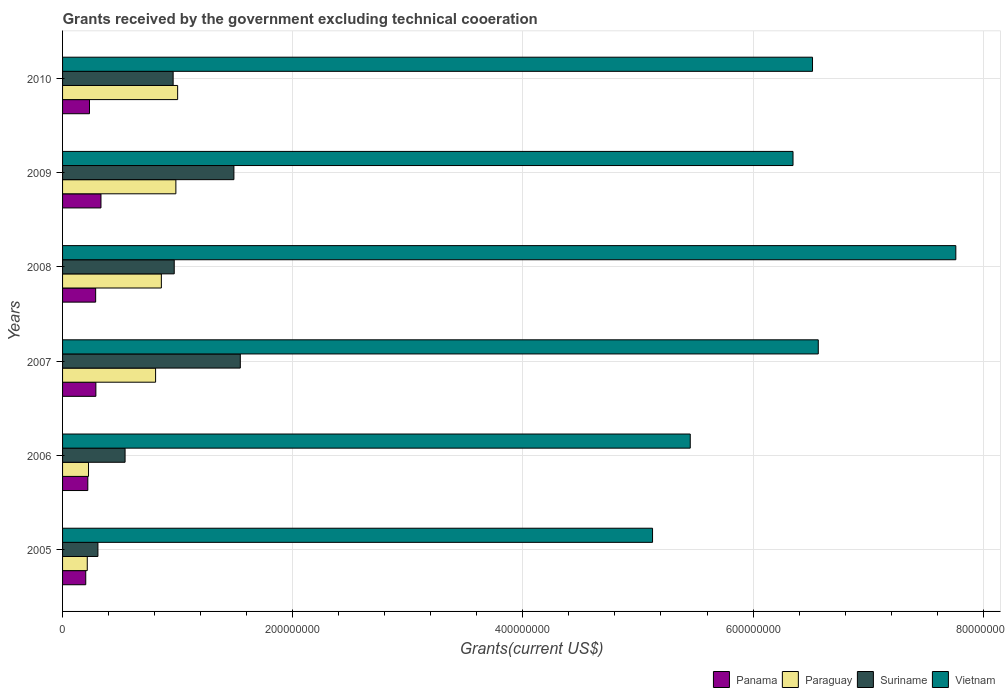Are the number of bars per tick equal to the number of legend labels?
Keep it short and to the point. Yes. Are the number of bars on each tick of the Y-axis equal?
Offer a very short reply. Yes. How many bars are there on the 6th tick from the bottom?
Your response must be concise. 4. What is the label of the 6th group of bars from the top?
Provide a succinct answer. 2005. In how many cases, is the number of bars for a given year not equal to the number of legend labels?
Your answer should be very brief. 0. What is the total grants received by the government in Panama in 2005?
Make the answer very short. 2.02e+07. Across all years, what is the maximum total grants received by the government in Panama?
Offer a terse response. 3.34e+07. Across all years, what is the minimum total grants received by the government in Vietnam?
Keep it short and to the point. 5.13e+08. In which year was the total grants received by the government in Vietnam maximum?
Offer a terse response. 2008. In which year was the total grants received by the government in Panama minimum?
Provide a short and direct response. 2005. What is the total total grants received by the government in Vietnam in the graph?
Your answer should be very brief. 3.78e+09. What is the difference between the total grants received by the government in Paraguay in 2009 and that in 2010?
Give a very brief answer. -1.53e+06. What is the difference between the total grants received by the government in Paraguay in 2006 and the total grants received by the government in Suriname in 2007?
Provide a short and direct response. -1.32e+08. What is the average total grants received by the government in Paraguay per year?
Offer a terse response. 6.82e+07. In the year 2008, what is the difference between the total grants received by the government in Panama and total grants received by the government in Vietnam?
Your response must be concise. -7.47e+08. In how many years, is the total grants received by the government in Paraguay greater than 160000000 US$?
Provide a succinct answer. 0. What is the ratio of the total grants received by the government in Paraguay in 2006 to that in 2009?
Provide a short and direct response. 0.23. Is the total grants received by the government in Panama in 2007 less than that in 2008?
Offer a very short reply. No. Is the difference between the total grants received by the government in Panama in 2006 and 2007 greater than the difference between the total grants received by the government in Vietnam in 2006 and 2007?
Ensure brevity in your answer.  Yes. What is the difference between the highest and the second highest total grants received by the government in Vietnam?
Make the answer very short. 1.20e+08. What is the difference between the highest and the lowest total grants received by the government in Paraguay?
Make the answer very short. 7.85e+07. Is the sum of the total grants received by the government in Suriname in 2005 and 2010 greater than the maximum total grants received by the government in Panama across all years?
Make the answer very short. Yes. What does the 2nd bar from the top in 2006 represents?
Provide a short and direct response. Suriname. What does the 3rd bar from the bottom in 2006 represents?
Keep it short and to the point. Suriname. Is it the case that in every year, the sum of the total grants received by the government in Vietnam and total grants received by the government in Suriname is greater than the total grants received by the government in Panama?
Make the answer very short. Yes. What is the difference between two consecutive major ticks on the X-axis?
Ensure brevity in your answer.  2.00e+08. Does the graph contain any zero values?
Make the answer very short. No. Where does the legend appear in the graph?
Make the answer very short. Bottom right. What is the title of the graph?
Ensure brevity in your answer.  Grants received by the government excluding technical cooeration. Does "Ethiopia" appear as one of the legend labels in the graph?
Make the answer very short. No. What is the label or title of the X-axis?
Keep it short and to the point. Grants(current US$). What is the label or title of the Y-axis?
Your answer should be very brief. Years. What is the Grants(current US$) in Panama in 2005?
Ensure brevity in your answer.  2.02e+07. What is the Grants(current US$) of Paraguay in 2005?
Your answer should be compact. 2.15e+07. What is the Grants(current US$) in Suriname in 2005?
Give a very brief answer. 3.07e+07. What is the Grants(current US$) in Vietnam in 2005?
Your response must be concise. 5.13e+08. What is the Grants(current US$) in Panama in 2006?
Provide a short and direct response. 2.19e+07. What is the Grants(current US$) in Paraguay in 2006?
Give a very brief answer. 2.26e+07. What is the Grants(current US$) of Suriname in 2006?
Your answer should be compact. 5.43e+07. What is the Grants(current US$) in Vietnam in 2006?
Your response must be concise. 5.45e+08. What is the Grants(current US$) of Panama in 2007?
Provide a short and direct response. 2.90e+07. What is the Grants(current US$) of Paraguay in 2007?
Give a very brief answer. 8.08e+07. What is the Grants(current US$) in Suriname in 2007?
Ensure brevity in your answer.  1.54e+08. What is the Grants(current US$) in Vietnam in 2007?
Provide a short and direct response. 6.57e+08. What is the Grants(current US$) in Panama in 2008?
Keep it short and to the point. 2.88e+07. What is the Grants(current US$) of Paraguay in 2008?
Keep it short and to the point. 8.58e+07. What is the Grants(current US$) in Suriname in 2008?
Your response must be concise. 9.70e+07. What is the Grants(current US$) in Vietnam in 2008?
Give a very brief answer. 7.76e+08. What is the Grants(current US$) in Panama in 2009?
Ensure brevity in your answer.  3.34e+07. What is the Grants(current US$) of Paraguay in 2009?
Offer a very short reply. 9.85e+07. What is the Grants(current US$) of Suriname in 2009?
Your answer should be compact. 1.49e+08. What is the Grants(current US$) of Vietnam in 2009?
Give a very brief answer. 6.35e+08. What is the Grants(current US$) in Panama in 2010?
Provide a short and direct response. 2.34e+07. What is the Grants(current US$) of Paraguay in 2010?
Make the answer very short. 1.00e+08. What is the Grants(current US$) of Suriname in 2010?
Provide a succinct answer. 9.61e+07. What is the Grants(current US$) of Vietnam in 2010?
Give a very brief answer. 6.52e+08. Across all years, what is the maximum Grants(current US$) of Panama?
Provide a succinct answer. 3.34e+07. Across all years, what is the maximum Grants(current US$) of Paraguay?
Offer a very short reply. 1.00e+08. Across all years, what is the maximum Grants(current US$) of Suriname?
Offer a terse response. 1.54e+08. Across all years, what is the maximum Grants(current US$) of Vietnam?
Offer a very short reply. 7.76e+08. Across all years, what is the minimum Grants(current US$) of Panama?
Offer a terse response. 2.02e+07. Across all years, what is the minimum Grants(current US$) in Paraguay?
Provide a succinct answer. 2.15e+07. Across all years, what is the minimum Grants(current US$) of Suriname?
Keep it short and to the point. 3.07e+07. Across all years, what is the minimum Grants(current US$) of Vietnam?
Your response must be concise. 5.13e+08. What is the total Grants(current US$) of Panama in the graph?
Offer a very short reply. 1.57e+08. What is the total Grants(current US$) of Paraguay in the graph?
Make the answer very short. 4.09e+08. What is the total Grants(current US$) of Suriname in the graph?
Your answer should be compact. 5.82e+08. What is the total Grants(current US$) in Vietnam in the graph?
Ensure brevity in your answer.  3.78e+09. What is the difference between the Grants(current US$) in Panama in 2005 and that in 2006?
Give a very brief answer. -1.79e+06. What is the difference between the Grants(current US$) in Paraguay in 2005 and that in 2006?
Provide a short and direct response. -1.09e+06. What is the difference between the Grants(current US$) of Suriname in 2005 and that in 2006?
Provide a succinct answer. -2.36e+07. What is the difference between the Grants(current US$) in Vietnam in 2005 and that in 2006?
Offer a terse response. -3.28e+07. What is the difference between the Grants(current US$) of Panama in 2005 and that in 2007?
Provide a short and direct response. -8.80e+06. What is the difference between the Grants(current US$) of Paraguay in 2005 and that in 2007?
Ensure brevity in your answer.  -5.94e+07. What is the difference between the Grants(current US$) in Suriname in 2005 and that in 2007?
Your response must be concise. -1.24e+08. What is the difference between the Grants(current US$) of Vietnam in 2005 and that in 2007?
Ensure brevity in your answer.  -1.44e+08. What is the difference between the Grants(current US$) of Panama in 2005 and that in 2008?
Ensure brevity in your answer.  -8.61e+06. What is the difference between the Grants(current US$) in Paraguay in 2005 and that in 2008?
Offer a very short reply. -6.44e+07. What is the difference between the Grants(current US$) in Suriname in 2005 and that in 2008?
Give a very brief answer. -6.63e+07. What is the difference between the Grants(current US$) of Vietnam in 2005 and that in 2008?
Your answer should be very brief. -2.64e+08. What is the difference between the Grants(current US$) in Panama in 2005 and that in 2009?
Offer a terse response. -1.32e+07. What is the difference between the Grants(current US$) of Paraguay in 2005 and that in 2009?
Provide a succinct answer. -7.70e+07. What is the difference between the Grants(current US$) of Suriname in 2005 and that in 2009?
Provide a succinct answer. -1.18e+08. What is the difference between the Grants(current US$) in Vietnam in 2005 and that in 2009?
Keep it short and to the point. -1.22e+08. What is the difference between the Grants(current US$) in Panama in 2005 and that in 2010?
Your answer should be compact. -3.26e+06. What is the difference between the Grants(current US$) in Paraguay in 2005 and that in 2010?
Your response must be concise. -7.85e+07. What is the difference between the Grants(current US$) of Suriname in 2005 and that in 2010?
Offer a terse response. -6.54e+07. What is the difference between the Grants(current US$) of Vietnam in 2005 and that in 2010?
Offer a very short reply. -1.39e+08. What is the difference between the Grants(current US$) of Panama in 2006 and that in 2007?
Provide a succinct answer. -7.01e+06. What is the difference between the Grants(current US$) in Paraguay in 2006 and that in 2007?
Offer a very short reply. -5.83e+07. What is the difference between the Grants(current US$) of Suriname in 2006 and that in 2007?
Keep it short and to the point. -1.00e+08. What is the difference between the Grants(current US$) in Vietnam in 2006 and that in 2007?
Offer a very short reply. -1.11e+08. What is the difference between the Grants(current US$) of Panama in 2006 and that in 2008?
Offer a very short reply. -6.82e+06. What is the difference between the Grants(current US$) in Paraguay in 2006 and that in 2008?
Your answer should be very brief. -6.33e+07. What is the difference between the Grants(current US$) in Suriname in 2006 and that in 2008?
Your answer should be compact. -4.27e+07. What is the difference between the Grants(current US$) of Vietnam in 2006 and that in 2008?
Your answer should be very brief. -2.31e+08. What is the difference between the Grants(current US$) of Panama in 2006 and that in 2009?
Your answer should be compact. -1.14e+07. What is the difference between the Grants(current US$) in Paraguay in 2006 and that in 2009?
Offer a very short reply. -7.59e+07. What is the difference between the Grants(current US$) in Suriname in 2006 and that in 2009?
Ensure brevity in your answer.  -9.46e+07. What is the difference between the Grants(current US$) in Vietnam in 2006 and that in 2009?
Keep it short and to the point. -8.93e+07. What is the difference between the Grants(current US$) of Panama in 2006 and that in 2010?
Your response must be concise. -1.47e+06. What is the difference between the Grants(current US$) in Paraguay in 2006 and that in 2010?
Make the answer very short. -7.74e+07. What is the difference between the Grants(current US$) of Suriname in 2006 and that in 2010?
Make the answer very short. -4.18e+07. What is the difference between the Grants(current US$) in Vietnam in 2006 and that in 2010?
Your response must be concise. -1.06e+08. What is the difference between the Grants(current US$) of Panama in 2007 and that in 2008?
Make the answer very short. 1.90e+05. What is the difference between the Grants(current US$) of Paraguay in 2007 and that in 2008?
Provide a short and direct response. -5.01e+06. What is the difference between the Grants(current US$) of Suriname in 2007 and that in 2008?
Provide a short and direct response. 5.74e+07. What is the difference between the Grants(current US$) of Vietnam in 2007 and that in 2008?
Your answer should be compact. -1.20e+08. What is the difference between the Grants(current US$) of Panama in 2007 and that in 2009?
Offer a terse response. -4.42e+06. What is the difference between the Grants(current US$) in Paraguay in 2007 and that in 2009?
Your answer should be very brief. -1.76e+07. What is the difference between the Grants(current US$) in Suriname in 2007 and that in 2009?
Your response must be concise. 5.56e+06. What is the difference between the Grants(current US$) of Vietnam in 2007 and that in 2009?
Your response must be concise. 2.20e+07. What is the difference between the Grants(current US$) in Panama in 2007 and that in 2010?
Your answer should be very brief. 5.54e+06. What is the difference between the Grants(current US$) of Paraguay in 2007 and that in 2010?
Provide a succinct answer. -1.92e+07. What is the difference between the Grants(current US$) of Suriname in 2007 and that in 2010?
Ensure brevity in your answer.  5.84e+07. What is the difference between the Grants(current US$) in Vietnam in 2007 and that in 2010?
Offer a very short reply. 5.01e+06. What is the difference between the Grants(current US$) of Panama in 2008 and that in 2009?
Provide a succinct answer. -4.61e+06. What is the difference between the Grants(current US$) in Paraguay in 2008 and that in 2009?
Your response must be concise. -1.26e+07. What is the difference between the Grants(current US$) in Suriname in 2008 and that in 2009?
Make the answer very short. -5.19e+07. What is the difference between the Grants(current US$) in Vietnam in 2008 and that in 2009?
Offer a terse response. 1.41e+08. What is the difference between the Grants(current US$) of Panama in 2008 and that in 2010?
Your response must be concise. 5.35e+06. What is the difference between the Grants(current US$) in Paraguay in 2008 and that in 2010?
Offer a terse response. -1.41e+07. What is the difference between the Grants(current US$) in Suriname in 2008 and that in 2010?
Offer a terse response. 9.40e+05. What is the difference between the Grants(current US$) in Vietnam in 2008 and that in 2010?
Your response must be concise. 1.25e+08. What is the difference between the Grants(current US$) of Panama in 2009 and that in 2010?
Keep it short and to the point. 9.96e+06. What is the difference between the Grants(current US$) in Paraguay in 2009 and that in 2010?
Ensure brevity in your answer.  -1.53e+06. What is the difference between the Grants(current US$) of Suriname in 2009 and that in 2010?
Offer a terse response. 5.28e+07. What is the difference between the Grants(current US$) of Vietnam in 2009 and that in 2010?
Provide a short and direct response. -1.70e+07. What is the difference between the Grants(current US$) in Panama in 2005 and the Grants(current US$) in Paraguay in 2006?
Make the answer very short. -2.40e+06. What is the difference between the Grants(current US$) in Panama in 2005 and the Grants(current US$) in Suriname in 2006?
Your response must be concise. -3.42e+07. What is the difference between the Grants(current US$) of Panama in 2005 and the Grants(current US$) of Vietnam in 2006?
Give a very brief answer. -5.25e+08. What is the difference between the Grants(current US$) of Paraguay in 2005 and the Grants(current US$) of Suriname in 2006?
Give a very brief answer. -3.29e+07. What is the difference between the Grants(current US$) in Paraguay in 2005 and the Grants(current US$) in Vietnam in 2006?
Provide a succinct answer. -5.24e+08. What is the difference between the Grants(current US$) in Suriname in 2005 and the Grants(current US$) in Vietnam in 2006?
Make the answer very short. -5.15e+08. What is the difference between the Grants(current US$) of Panama in 2005 and the Grants(current US$) of Paraguay in 2007?
Make the answer very short. -6.07e+07. What is the difference between the Grants(current US$) in Panama in 2005 and the Grants(current US$) in Suriname in 2007?
Ensure brevity in your answer.  -1.34e+08. What is the difference between the Grants(current US$) in Panama in 2005 and the Grants(current US$) in Vietnam in 2007?
Provide a succinct answer. -6.37e+08. What is the difference between the Grants(current US$) in Paraguay in 2005 and the Grants(current US$) in Suriname in 2007?
Offer a terse response. -1.33e+08. What is the difference between the Grants(current US$) in Paraguay in 2005 and the Grants(current US$) in Vietnam in 2007?
Offer a terse response. -6.35e+08. What is the difference between the Grants(current US$) of Suriname in 2005 and the Grants(current US$) of Vietnam in 2007?
Your answer should be very brief. -6.26e+08. What is the difference between the Grants(current US$) in Panama in 2005 and the Grants(current US$) in Paraguay in 2008?
Ensure brevity in your answer.  -6.57e+07. What is the difference between the Grants(current US$) in Panama in 2005 and the Grants(current US$) in Suriname in 2008?
Give a very brief answer. -7.69e+07. What is the difference between the Grants(current US$) of Panama in 2005 and the Grants(current US$) of Vietnam in 2008?
Make the answer very short. -7.56e+08. What is the difference between the Grants(current US$) in Paraguay in 2005 and the Grants(current US$) in Suriname in 2008?
Give a very brief answer. -7.56e+07. What is the difference between the Grants(current US$) in Paraguay in 2005 and the Grants(current US$) in Vietnam in 2008?
Offer a very short reply. -7.55e+08. What is the difference between the Grants(current US$) of Suriname in 2005 and the Grants(current US$) of Vietnam in 2008?
Your answer should be very brief. -7.45e+08. What is the difference between the Grants(current US$) in Panama in 2005 and the Grants(current US$) in Paraguay in 2009?
Ensure brevity in your answer.  -7.83e+07. What is the difference between the Grants(current US$) of Panama in 2005 and the Grants(current US$) of Suriname in 2009?
Your answer should be compact. -1.29e+08. What is the difference between the Grants(current US$) of Panama in 2005 and the Grants(current US$) of Vietnam in 2009?
Provide a short and direct response. -6.15e+08. What is the difference between the Grants(current US$) of Paraguay in 2005 and the Grants(current US$) of Suriname in 2009?
Make the answer very short. -1.27e+08. What is the difference between the Grants(current US$) of Paraguay in 2005 and the Grants(current US$) of Vietnam in 2009?
Offer a very short reply. -6.13e+08. What is the difference between the Grants(current US$) in Suriname in 2005 and the Grants(current US$) in Vietnam in 2009?
Make the answer very short. -6.04e+08. What is the difference between the Grants(current US$) in Panama in 2005 and the Grants(current US$) in Paraguay in 2010?
Offer a very short reply. -7.98e+07. What is the difference between the Grants(current US$) in Panama in 2005 and the Grants(current US$) in Suriname in 2010?
Give a very brief answer. -7.59e+07. What is the difference between the Grants(current US$) in Panama in 2005 and the Grants(current US$) in Vietnam in 2010?
Make the answer very short. -6.32e+08. What is the difference between the Grants(current US$) of Paraguay in 2005 and the Grants(current US$) of Suriname in 2010?
Offer a very short reply. -7.46e+07. What is the difference between the Grants(current US$) in Paraguay in 2005 and the Grants(current US$) in Vietnam in 2010?
Provide a short and direct response. -6.30e+08. What is the difference between the Grants(current US$) in Suriname in 2005 and the Grants(current US$) in Vietnam in 2010?
Offer a very short reply. -6.21e+08. What is the difference between the Grants(current US$) in Panama in 2006 and the Grants(current US$) in Paraguay in 2007?
Keep it short and to the point. -5.89e+07. What is the difference between the Grants(current US$) of Panama in 2006 and the Grants(current US$) of Suriname in 2007?
Provide a succinct answer. -1.33e+08. What is the difference between the Grants(current US$) in Panama in 2006 and the Grants(current US$) in Vietnam in 2007?
Make the answer very short. -6.35e+08. What is the difference between the Grants(current US$) of Paraguay in 2006 and the Grants(current US$) of Suriname in 2007?
Offer a terse response. -1.32e+08. What is the difference between the Grants(current US$) of Paraguay in 2006 and the Grants(current US$) of Vietnam in 2007?
Offer a terse response. -6.34e+08. What is the difference between the Grants(current US$) in Suriname in 2006 and the Grants(current US$) in Vietnam in 2007?
Offer a terse response. -6.02e+08. What is the difference between the Grants(current US$) in Panama in 2006 and the Grants(current US$) in Paraguay in 2008?
Your answer should be compact. -6.39e+07. What is the difference between the Grants(current US$) of Panama in 2006 and the Grants(current US$) of Suriname in 2008?
Provide a short and direct response. -7.51e+07. What is the difference between the Grants(current US$) of Panama in 2006 and the Grants(current US$) of Vietnam in 2008?
Offer a terse response. -7.54e+08. What is the difference between the Grants(current US$) in Paraguay in 2006 and the Grants(current US$) in Suriname in 2008?
Make the answer very short. -7.45e+07. What is the difference between the Grants(current US$) in Paraguay in 2006 and the Grants(current US$) in Vietnam in 2008?
Make the answer very short. -7.54e+08. What is the difference between the Grants(current US$) in Suriname in 2006 and the Grants(current US$) in Vietnam in 2008?
Keep it short and to the point. -7.22e+08. What is the difference between the Grants(current US$) in Panama in 2006 and the Grants(current US$) in Paraguay in 2009?
Provide a short and direct response. -7.65e+07. What is the difference between the Grants(current US$) of Panama in 2006 and the Grants(current US$) of Suriname in 2009?
Your answer should be very brief. -1.27e+08. What is the difference between the Grants(current US$) of Panama in 2006 and the Grants(current US$) of Vietnam in 2009?
Your answer should be compact. -6.13e+08. What is the difference between the Grants(current US$) of Paraguay in 2006 and the Grants(current US$) of Suriname in 2009?
Make the answer very short. -1.26e+08. What is the difference between the Grants(current US$) of Paraguay in 2006 and the Grants(current US$) of Vietnam in 2009?
Offer a very short reply. -6.12e+08. What is the difference between the Grants(current US$) in Suriname in 2006 and the Grants(current US$) in Vietnam in 2009?
Your answer should be compact. -5.80e+08. What is the difference between the Grants(current US$) of Panama in 2006 and the Grants(current US$) of Paraguay in 2010?
Provide a succinct answer. -7.80e+07. What is the difference between the Grants(current US$) of Panama in 2006 and the Grants(current US$) of Suriname in 2010?
Provide a succinct answer. -7.42e+07. What is the difference between the Grants(current US$) of Panama in 2006 and the Grants(current US$) of Vietnam in 2010?
Provide a short and direct response. -6.30e+08. What is the difference between the Grants(current US$) in Paraguay in 2006 and the Grants(current US$) in Suriname in 2010?
Your response must be concise. -7.35e+07. What is the difference between the Grants(current US$) in Paraguay in 2006 and the Grants(current US$) in Vietnam in 2010?
Make the answer very short. -6.29e+08. What is the difference between the Grants(current US$) in Suriname in 2006 and the Grants(current US$) in Vietnam in 2010?
Your response must be concise. -5.97e+08. What is the difference between the Grants(current US$) in Panama in 2007 and the Grants(current US$) in Paraguay in 2008?
Give a very brief answer. -5.69e+07. What is the difference between the Grants(current US$) of Panama in 2007 and the Grants(current US$) of Suriname in 2008?
Ensure brevity in your answer.  -6.81e+07. What is the difference between the Grants(current US$) of Panama in 2007 and the Grants(current US$) of Vietnam in 2008?
Provide a succinct answer. -7.47e+08. What is the difference between the Grants(current US$) of Paraguay in 2007 and the Grants(current US$) of Suriname in 2008?
Your answer should be compact. -1.62e+07. What is the difference between the Grants(current US$) of Paraguay in 2007 and the Grants(current US$) of Vietnam in 2008?
Ensure brevity in your answer.  -6.95e+08. What is the difference between the Grants(current US$) of Suriname in 2007 and the Grants(current US$) of Vietnam in 2008?
Offer a very short reply. -6.22e+08. What is the difference between the Grants(current US$) of Panama in 2007 and the Grants(current US$) of Paraguay in 2009?
Make the answer very short. -6.95e+07. What is the difference between the Grants(current US$) of Panama in 2007 and the Grants(current US$) of Suriname in 2009?
Keep it short and to the point. -1.20e+08. What is the difference between the Grants(current US$) in Panama in 2007 and the Grants(current US$) in Vietnam in 2009?
Offer a terse response. -6.06e+08. What is the difference between the Grants(current US$) in Paraguay in 2007 and the Grants(current US$) in Suriname in 2009?
Provide a succinct answer. -6.80e+07. What is the difference between the Grants(current US$) in Paraguay in 2007 and the Grants(current US$) in Vietnam in 2009?
Give a very brief answer. -5.54e+08. What is the difference between the Grants(current US$) in Suriname in 2007 and the Grants(current US$) in Vietnam in 2009?
Ensure brevity in your answer.  -4.80e+08. What is the difference between the Grants(current US$) of Panama in 2007 and the Grants(current US$) of Paraguay in 2010?
Provide a short and direct response. -7.10e+07. What is the difference between the Grants(current US$) of Panama in 2007 and the Grants(current US$) of Suriname in 2010?
Your answer should be compact. -6.71e+07. What is the difference between the Grants(current US$) in Panama in 2007 and the Grants(current US$) in Vietnam in 2010?
Ensure brevity in your answer.  -6.23e+08. What is the difference between the Grants(current US$) of Paraguay in 2007 and the Grants(current US$) of Suriname in 2010?
Give a very brief answer. -1.52e+07. What is the difference between the Grants(current US$) of Paraguay in 2007 and the Grants(current US$) of Vietnam in 2010?
Give a very brief answer. -5.71e+08. What is the difference between the Grants(current US$) of Suriname in 2007 and the Grants(current US$) of Vietnam in 2010?
Your answer should be very brief. -4.97e+08. What is the difference between the Grants(current US$) of Panama in 2008 and the Grants(current US$) of Paraguay in 2009?
Give a very brief answer. -6.97e+07. What is the difference between the Grants(current US$) in Panama in 2008 and the Grants(current US$) in Suriname in 2009?
Provide a short and direct response. -1.20e+08. What is the difference between the Grants(current US$) in Panama in 2008 and the Grants(current US$) in Vietnam in 2009?
Keep it short and to the point. -6.06e+08. What is the difference between the Grants(current US$) in Paraguay in 2008 and the Grants(current US$) in Suriname in 2009?
Your answer should be very brief. -6.30e+07. What is the difference between the Grants(current US$) in Paraguay in 2008 and the Grants(current US$) in Vietnam in 2009?
Your answer should be compact. -5.49e+08. What is the difference between the Grants(current US$) of Suriname in 2008 and the Grants(current US$) of Vietnam in 2009?
Your response must be concise. -5.38e+08. What is the difference between the Grants(current US$) in Panama in 2008 and the Grants(current US$) in Paraguay in 2010?
Your response must be concise. -7.12e+07. What is the difference between the Grants(current US$) of Panama in 2008 and the Grants(current US$) of Suriname in 2010?
Give a very brief answer. -6.73e+07. What is the difference between the Grants(current US$) of Panama in 2008 and the Grants(current US$) of Vietnam in 2010?
Make the answer very short. -6.23e+08. What is the difference between the Grants(current US$) of Paraguay in 2008 and the Grants(current US$) of Suriname in 2010?
Ensure brevity in your answer.  -1.02e+07. What is the difference between the Grants(current US$) of Paraguay in 2008 and the Grants(current US$) of Vietnam in 2010?
Your answer should be very brief. -5.66e+08. What is the difference between the Grants(current US$) in Suriname in 2008 and the Grants(current US$) in Vietnam in 2010?
Your answer should be very brief. -5.55e+08. What is the difference between the Grants(current US$) in Panama in 2009 and the Grants(current US$) in Paraguay in 2010?
Your response must be concise. -6.66e+07. What is the difference between the Grants(current US$) of Panama in 2009 and the Grants(current US$) of Suriname in 2010?
Your answer should be compact. -6.27e+07. What is the difference between the Grants(current US$) of Panama in 2009 and the Grants(current US$) of Vietnam in 2010?
Offer a terse response. -6.18e+08. What is the difference between the Grants(current US$) in Paraguay in 2009 and the Grants(current US$) in Suriname in 2010?
Your answer should be very brief. 2.37e+06. What is the difference between the Grants(current US$) in Paraguay in 2009 and the Grants(current US$) in Vietnam in 2010?
Your answer should be very brief. -5.53e+08. What is the difference between the Grants(current US$) in Suriname in 2009 and the Grants(current US$) in Vietnam in 2010?
Offer a very short reply. -5.03e+08. What is the average Grants(current US$) in Panama per year?
Your answer should be very brief. 2.61e+07. What is the average Grants(current US$) in Paraguay per year?
Make the answer very short. 6.82e+07. What is the average Grants(current US$) of Suriname per year?
Provide a succinct answer. 9.69e+07. What is the average Grants(current US$) in Vietnam per year?
Keep it short and to the point. 6.30e+08. In the year 2005, what is the difference between the Grants(current US$) in Panama and Grants(current US$) in Paraguay?
Provide a short and direct response. -1.31e+06. In the year 2005, what is the difference between the Grants(current US$) of Panama and Grants(current US$) of Suriname?
Ensure brevity in your answer.  -1.06e+07. In the year 2005, what is the difference between the Grants(current US$) of Panama and Grants(current US$) of Vietnam?
Your answer should be very brief. -4.93e+08. In the year 2005, what is the difference between the Grants(current US$) in Paraguay and Grants(current US$) in Suriname?
Your response must be concise. -9.26e+06. In the year 2005, what is the difference between the Grants(current US$) in Paraguay and Grants(current US$) in Vietnam?
Offer a very short reply. -4.91e+08. In the year 2005, what is the difference between the Grants(current US$) of Suriname and Grants(current US$) of Vietnam?
Provide a short and direct response. -4.82e+08. In the year 2006, what is the difference between the Grants(current US$) in Panama and Grants(current US$) in Paraguay?
Your response must be concise. -6.10e+05. In the year 2006, what is the difference between the Grants(current US$) in Panama and Grants(current US$) in Suriname?
Your answer should be very brief. -3.24e+07. In the year 2006, what is the difference between the Grants(current US$) of Panama and Grants(current US$) of Vietnam?
Offer a terse response. -5.23e+08. In the year 2006, what is the difference between the Grants(current US$) of Paraguay and Grants(current US$) of Suriname?
Give a very brief answer. -3.18e+07. In the year 2006, what is the difference between the Grants(current US$) of Paraguay and Grants(current US$) of Vietnam?
Make the answer very short. -5.23e+08. In the year 2006, what is the difference between the Grants(current US$) of Suriname and Grants(current US$) of Vietnam?
Give a very brief answer. -4.91e+08. In the year 2007, what is the difference between the Grants(current US$) of Panama and Grants(current US$) of Paraguay?
Offer a very short reply. -5.19e+07. In the year 2007, what is the difference between the Grants(current US$) in Panama and Grants(current US$) in Suriname?
Your answer should be very brief. -1.26e+08. In the year 2007, what is the difference between the Grants(current US$) of Panama and Grants(current US$) of Vietnam?
Provide a succinct answer. -6.28e+08. In the year 2007, what is the difference between the Grants(current US$) of Paraguay and Grants(current US$) of Suriname?
Offer a terse response. -7.36e+07. In the year 2007, what is the difference between the Grants(current US$) of Paraguay and Grants(current US$) of Vietnam?
Provide a short and direct response. -5.76e+08. In the year 2007, what is the difference between the Grants(current US$) in Suriname and Grants(current US$) in Vietnam?
Provide a succinct answer. -5.02e+08. In the year 2008, what is the difference between the Grants(current US$) in Panama and Grants(current US$) in Paraguay?
Your answer should be very brief. -5.71e+07. In the year 2008, what is the difference between the Grants(current US$) of Panama and Grants(current US$) of Suriname?
Keep it short and to the point. -6.83e+07. In the year 2008, what is the difference between the Grants(current US$) of Panama and Grants(current US$) of Vietnam?
Provide a succinct answer. -7.47e+08. In the year 2008, what is the difference between the Grants(current US$) of Paraguay and Grants(current US$) of Suriname?
Give a very brief answer. -1.12e+07. In the year 2008, what is the difference between the Grants(current US$) of Paraguay and Grants(current US$) of Vietnam?
Your answer should be very brief. -6.90e+08. In the year 2008, what is the difference between the Grants(current US$) of Suriname and Grants(current US$) of Vietnam?
Give a very brief answer. -6.79e+08. In the year 2009, what is the difference between the Grants(current US$) of Panama and Grants(current US$) of Paraguay?
Give a very brief answer. -6.51e+07. In the year 2009, what is the difference between the Grants(current US$) in Panama and Grants(current US$) in Suriname?
Keep it short and to the point. -1.16e+08. In the year 2009, what is the difference between the Grants(current US$) of Panama and Grants(current US$) of Vietnam?
Your response must be concise. -6.01e+08. In the year 2009, what is the difference between the Grants(current US$) of Paraguay and Grants(current US$) of Suriname?
Offer a very short reply. -5.04e+07. In the year 2009, what is the difference between the Grants(current US$) in Paraguay and Grants(current US$) in Vietnam?
Your answer should be very brief. -5.36e+08. In the year 2009, what is the difference between the Grants(current US$) of Suriname and Grants(current US$) of Vietnam?
Your answer should be compact. -4.86e+08. In the year 2010, what is the difference between the Grants(current US$) in Panama and Grants(current US$) in Paraguay?
Your response must be concise. -7.66e+07. In the year 2010, what is the difference between the Grants(current US$) of Panama and Grants(current US$) of Suriname?
Give a very brief answer. -7.27e+07. In the year 2010, what is the difference between the Grants(current US$) of Panama and Grants(current US$) of Vietnam?
Offer a very short reply. -6.28e+08. In the year 2010, what is the difference between the Grants(current US$) of Paraguay and Grants(current US$) of Suriname?
Give a very brief answer. 3.90e+06. In the year 2010, what is the difference between the Grants(current US$) of Paraguay and Grants(current US$) of Vietnam?
Ensure brevity in your answer.  -5.52e+08. In the year 2010, what is the difference between the Grants(current US$) of Suriname and Grants(current US$) of Vietnam?
Offer a terse response. -5.56e+08. What is the ratio of the Grants(current US$) in Panama in 2005 to that in 2006?
Your answer should be compact. 0.92. What is the ratio of the Grants(current US$) of Paraguay in 2005 to that in 2006?
Offer a terse response. 0.95. What is the ratio of the Grants(current US$) in Suriname in 2005 to that in 2006?
Provide a succinct answer. 0.57. What is the ratio of the Grants(current US$) of Vietnam in 2005 to that in 2006?
Make the answer very short. 0.94. What is the ratio of the Grants(current US$) in Panama in 2005 to that in 2007?
Your response must be concise. 0.7. What is the ratio of the Grants(current US$) in Paraguay in 2005 to that in 2007?
Your response must be concise. 0.27. What is the ratio of the Grants(current US$) in Suriname in 2005 to that in 2007?
Ensure brevity in your answer.  0.2. What is the ratio of the Grants(current US$) of Vietnam in 2005 to that in 2007?
Make the answer very short. 0.78. What is the ratio of the Grants(current US$) of Panama in 2005 to that in 2008?
Offer a terse response. 0.7. What is the ratio of the Grants(current US$) in Paraguay in 2005 to that in 2008?
Keep it short and to the point. 0.25. What is the ratio of the Grants(current US$) in Suriname in 2005 to that in 2008?
Offer a terse response. 0.32. What is the ratio of the Grants(current US$) of Vietnam in 2005 to that in 2008?
Give a very brief answer. 0.66. What is the ratio of the Grants(current US$) of Panama in 2005 to that in 2009?
Offer a terse response. 0.6. What is the ratio of the Grants(current US$) of Paraguay in 2005 to that in 2009?
Your response must be concise. 0.22. What is the ratio of the Grants(current US$) of Suriname in 2005 to that in 2009?
Provide a succinct answer. 0.21. What is the ratio of the Grants(current US$) of Vietnam in 2005 to that in 2009?
Give a very brief answer. 0.81. What is the ratio of the Grants(current US$) of Panama in 2005 to that in 2010?
Provide a short and direct response. 0.86. What is the ratio of the Grants(current US$) in Paraguay in 2005 to that in 2010?
Keep it short and to the point. 0.21. What is the ratio of the Grants(current US$) of Suriname in 2005 to that in 2010?
Offer a very short reply. 0.32. What is the ratio of the Grants(current US$) in Vietnam in 2005 to that in 2010?
Your answer should be very brief. 0.79. What is the ratio of the Grants(current US$) of Panama in 2006 to that in 2007?
Your answer should be compact. 0.76. What is the ratio of the Grants(current US$) of Paraguay in 2006 to that in 2007?
Give a very brief answer. 0.28. What is the ratio of the Grants(current US$) of Suriname in 2006 to that in 2007?
Ensure brevity in your answer.  0.35. What is the ratio of the Grants(current US$) of Vietnam in 2006 to that in 2007?
Your answer should be very brief. 0.83. What is the ratio of the Grants(current US$) of Panama in 2006 to that in 2008?
Ensure brevity in your answer.  0.76. What is the ratio of the Grants(current US$) of Paraguay in 2006 to that in 2008?
Provide a succinct answer. 0.26. What is the ratio of the Grants(current US$) in Suriname in 2006 to that in 2008?
Offer a very short reply. 0.56. What is the ratio of the Grants(current US$) in Vietnam in 2006 to that in 2008?
Your answer should be very brief. 0.7. What is the ratio of the Grants(current US$) of Panama in 2006 to that in 2009?
Provide a succinct answer. 0.66. What is the ratio of the Grants(current US$) of Paraguay in 2006 to that in 2009?
Your answer should be compact. 0.23. What is the ratio of the Grants(current US$) in Suriname in 2006 to that in 2009?
Provide a succinct answer. 0.36. What is the ratio of the Grants(current US$) in Vietnam in 2006 to that in 2009?
Your response must be concise. 0.86. What is the ratio of the Grants(current US$) of Panama in 2006 to that in 2010?
Ensure brevity in your answer.  0.94. What is the ratio of the Grants(current US$) of Paraguay in 2006 to that in 2010?
Your answer should be compact. 0.23. What is the ratio of the Grants(current US$) of Suriname in 2006 to that in 2010?
Provide a short and direct response. 0.57. What is the ratio of the Grants(current US$) of Vietnam in 2006 to that in 2010?
Give a very brief answer. 0.84. What is the ratio of the Grants(current US$) of Panama in 2007 to that in 2008?
Provide a short and direct response. 1.01. What is the ratio of the Grants(current US$) of Paraguay in 2007 to that in 2008?
Offer a terse response. 0.94. What is the ratio of the Grants(current US$) of Suriname in 2007 to that in 2008?
Make the answer very short. 1.59. What is the ratio of the Grants(current US$) in Vietnam in 2007 to that in 2008?
Make the answer very short. 0.85. What is the ratio of the Grants(current US$) of Panama in 2007 to that in 2009?
Make the answer very short. 0.87. What is the ratio of the Grants(current US$) in Paraguay in 2007 to that in 2009?
Keep it short and to the point. 0.82. What is the ratio of the Grants(current US$) in Suriname in 2007 to that in 2009?
Ensure brevity in your answer.  1.04. What is the ratio of the Grants(current US$) of Vietnam in 2007 to that in 2009?
Provide a succinct answer. 1.03. What is the ratio of the Grants(current US$) of Panama in 2007 to that in 2010?
Keep it short and to the point. 1.24. What is the ratio of the Grants(current US$) in Paraguay in 2007 to that in 2010?
Keep it short and to the point. 0.81. What is the ratio of the Grants(current US$) of Suriname in 2007 to that in 2010?
Your response must be concise. 1.61. What is the ratio of the Grants(current US$) in Vietnam in 2007 to that in 2010?
Keep it short and to the point. 1.01. What is the ratio of the Grants(current US$) of Panama in 2008 to that in 2009?
Your answer should be compact. 0.86. What is the ratio of the Grants(current US$) in Paraguay in 2008 to that in 2009?
Provide a succinct answer. 0.87. What is the ratio of the Grants(current US$) of Suriname in 2008 to that in 2009?
Make the answer very short. 0.65. What is the ratio of the Grants(current US$) in Vietnam in 2008 to that in 2009?
Offer a terse response. 1.22. What is the ratio of the Grants(current US$) in Panama in 2008 to that in 2010?
Make the answer very short. 1.23. What is the ratio of the Grants(current US$) of Paraguay in 2008 to that in 2010?
Your answer should be very brief. 0.86. What is the ratio of the Grants(current US$) of Suriname in 2008 to that in 2010?
Provide a succinct answer. 1.01. What is the ratio of the Grants(current US$) in Vietnam in 2008 to that in 2010?
Keep it short and to the point. 1.19. What is the ratio of the Grants(current US$) of Panama in 2009 to that in 2010?
Your answer should be compact. 1.43. What is the ratio of the Grants(current US$) of Paraguay in 2009 to that in 2010?
Your answer should be compact. 0.98. What is the ratio of the Grants(current US$) in Suriname in 2009 to that in 2010?
Your answer should be very brief. 1.55. What is the difference between the highest and the second highest Grants(current US$) of Panama?
Offer a terse response. 4.42e+06. What is the difference between the highest and the second highest Grants(current US$) in Paraguay?
Offer a very short reply. 1.53e+06. What is the difference between the highest and the second highest Grants(current US$) in Suriname?
Your answer should be compact. 5.56e+06. What is the difference between the highest and the second highest Grants(current US$) of Vietnam?
Provide a succinct answer. 1.20e+08. What is the difference between the highest and the lowest Grants(current US$) of Panama?
Offer a terse response. 1.32e+07. What is the difference between the highest and the lowest Grants(current US$) of Paraguay?
Provide a short and direct response. 7.85e+07. What is the difference between the highest and the lowest Grants(current US$) of Suriname?
Give a very brief answer. 1.24e+08. What is the difference between the highest and the lowest Grants(current US$) in Vietnam?
Keep it short and to the point. 2.64e+08. 